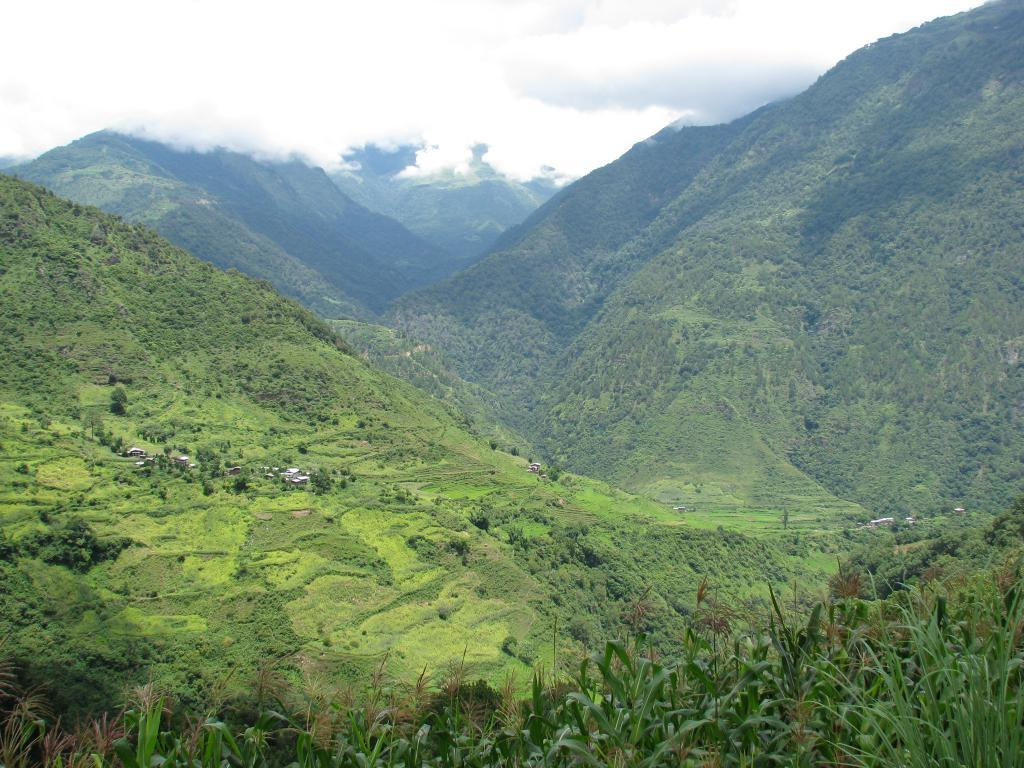What type of natural landform can be seen in the image? There are mountains in the image. What type of vegetation is present in the image? There are trees in the image. What part of the environment is visible in the image? The sky is visible in the image. What colors can be seen in the sky in the image? The sky has a combination of white and blue colors. How many bones are visible in the image? There are no bones present in the image. What is the amount of toes visible in the image? There are no toes visible in the image. 